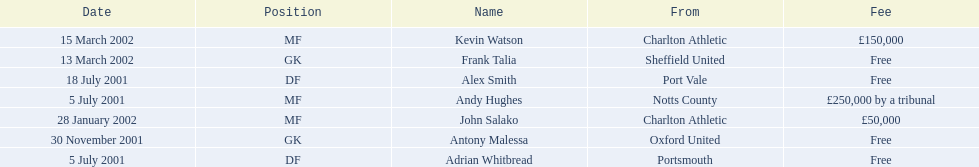What are all of the names? Andy Hughes, Adrian Whitbread, Alex Smith, Antony Malessa, John Salako, Frank Talia, Kevin Watson. What was the fee for each person? £250,000 by a tribunal, Free, Free, Free, £50,000, Free, £150,000. And who had the highest fee? Andy Hughes. 